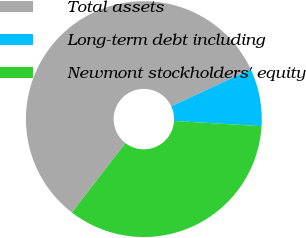Convert chart. <chart><loc_0><loc_0><loc_500><loc_500><pie_chart><fcel>Total assets<fcel>Long-term debt including<fcel>Newmont stockholders' equity<nl><fcel>57.61%<fcel>7.9%<fcel>34.49%<nl></chart> 